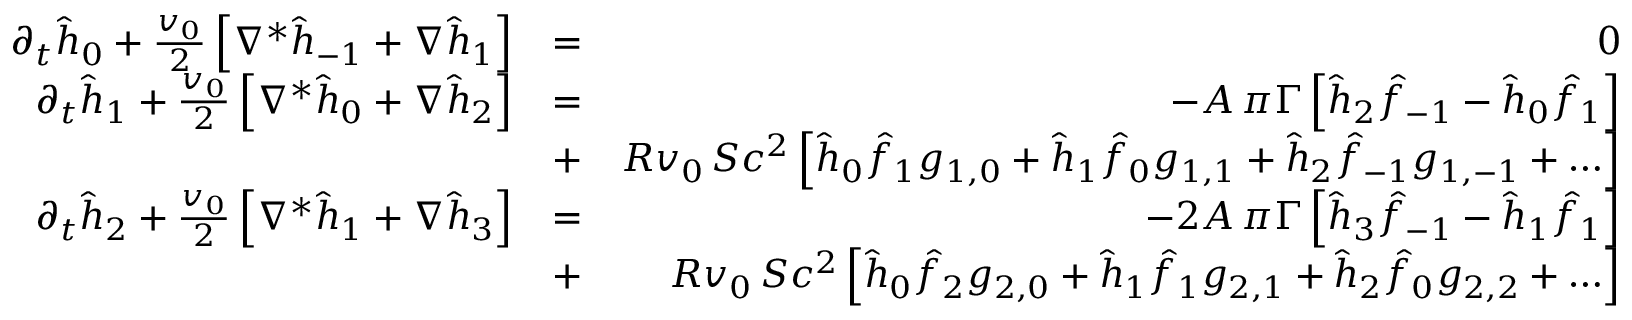Convert formula to latex. <formula><loc_0><loc_0><loc_500><loc_500>\begin{array} { r l r } { \partial _ { t } \hat { h } _ { 0 } + { \frac { v _ { 0 } } { 2 } } \left [ \nabla ^ { * } \hat { h } _ { - 1 } + \nabla \hat { h } _ { 1 } \right ] } & { = } & { 0 } \\ { \partial _ { t } \hat { h } _ { 1 } + { \frac { v _ { 0 } } { 2 } } \left [ \nabla ^ { * } \hat { h } _ { 0 } + \nabla \hat { h } _ { 2 } \right ] } & { = } & { - A \, \pi \Gamma \left [ \hat { h } _ { 2 } \hat { f } _ { - 1 } - \hat { h } _ { 0 } \hat { f } _ { 1 } \right ] } \\ & { + } & { R v _ { 0 } \, S c ^ { 2 } \left [ \hat { h } _ { 0 } \hat { f } _ { 1 } g _ { 1 , 0 } + \hat { h } _ { 1 } \hat { f } _ { 0 } g _ { 1 , 1 } + \hat { h } _ { 2 } \hat { f } _ { - 1 } g _ { 1 , - 1 } + \dots \right ] } \\ { \partial _ { t } \hat { h } _ { 2 } + { \frac { v _ { 0 } } { 2 } } \left [ \nabla ^ { * } \hat { h } _ { 1 } + \nabla \hat { h } _ { 3 } \right ] } & { = } & { - 2 A \, \pi \Gamma \left [ \hat { h } _ { 3 } \hat { f } _ { - 1 } - \hat { h } _ { 1 } \hat { f } _ { 1 } \right ] } \\ & { + } & { R v _ { 0 } \, S c ^ { 2 } \left [ \hat { h } _ { 0 } \hat { f } _ { 2 } g _ { 2 , 0 } + \hat { h } _ { 1 } \hat { f } _ { 1 } g _ { 2 , 1 } + \hat { h } _ { 2 } \hat { f } _ { 0 } g _ { 2 , 2 } + \dots \right ] } \end{array}</formula> 